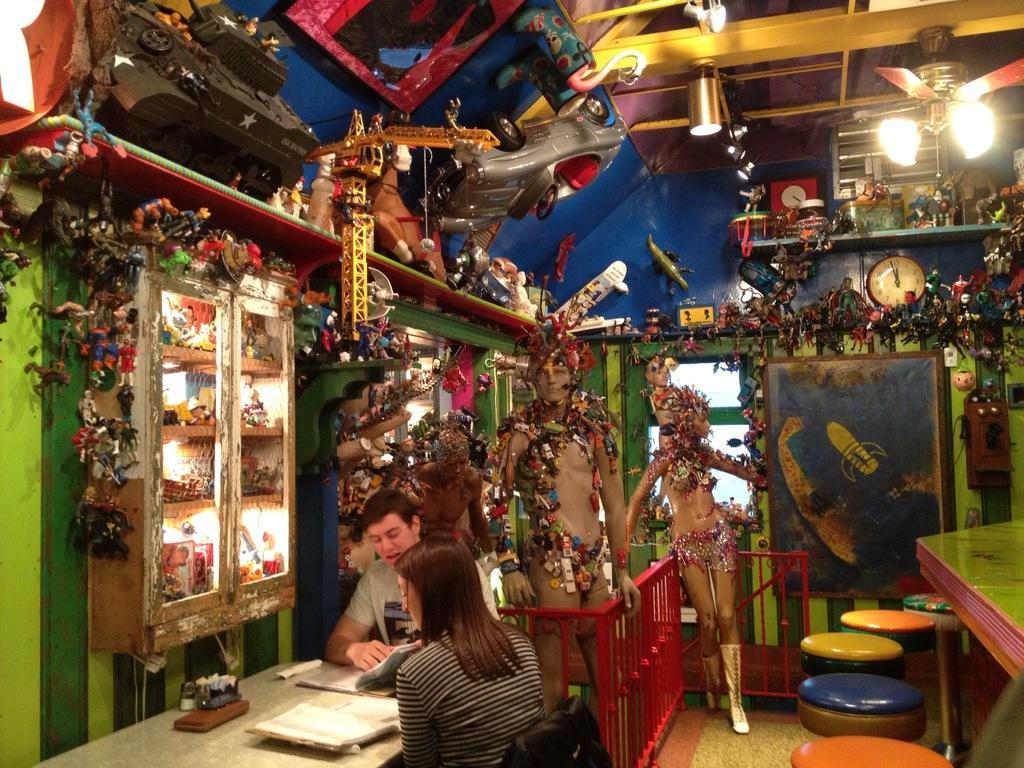Please provide a concise description of this image. In this picture we can see two people are seated on the chair, in front of them we can find couple of books on the table and also we can see couple of toys in the room, and we can see couple of wall clocks, lights and a fan. 